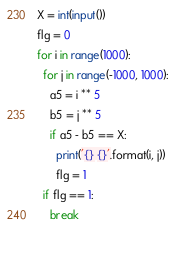Convert code to text. <code><loc_0><loc_0><loc_500><loc_500><_Python_>X = int(input())
flg = 0
for i in range(1000):
  for j in range(-1000, 1000):
    a5 = i ** 5
    b5 = j ** 5
    if a5 - b5 == X:
      print('{} {}'.format(i, j))
      flg = 1
  if flg == 1:
    break
  
      </code> 